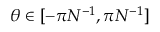Convert formula to latex. <formula><loc_0><loc_0><loc_500><loc_500>\theta \in [ - \pi N ^ { - 1 } , \pi N ^ { - 1 } ]</formula> 